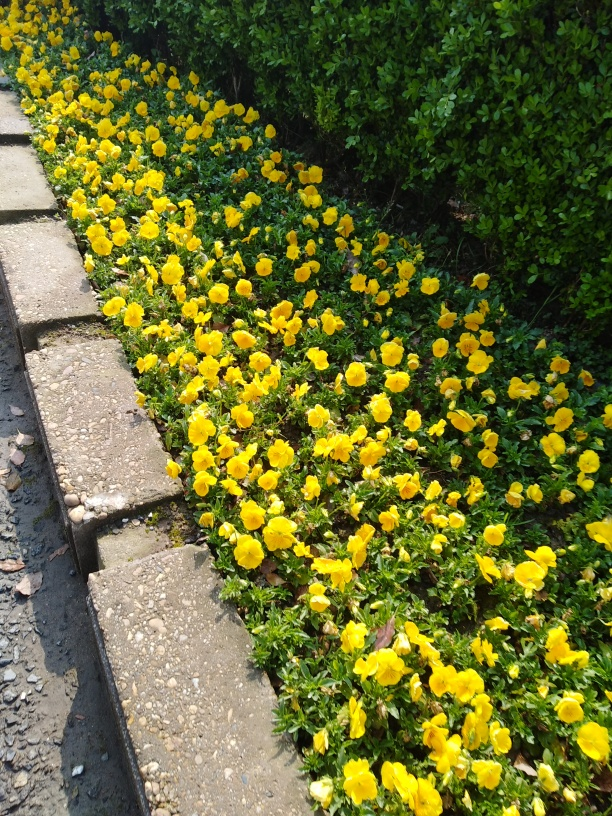What type of flowers are these? These appear to be bright yellow pansies, which are common garden flowers known for their vibrant colors and distinctive patterns. Is it possible to tell the season from this image? The lush greenery and blooming flowers suggest it's spring or summer, which are the seasons when pansies typically thrive. 